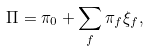<formula> <loc_0><loc_0><loc_500><loc_500>\Pi = \pi _ { 0 } + \sum _ { f } \pi _ { f } \xi _ { f } ,</formula> 